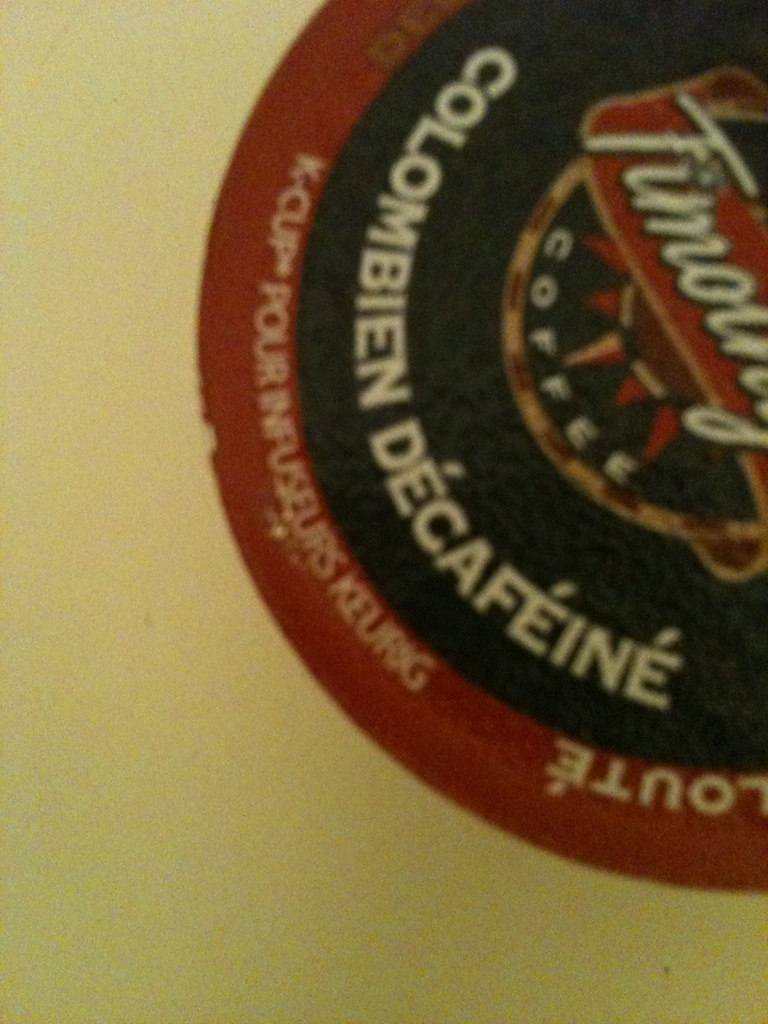What kind of coffee is this? Is it flavored? This is a decaffeinated Colombian coffee. Based on the image, it doesn't appear to be flavored as it does not indicate any specific flavoring on the label. 